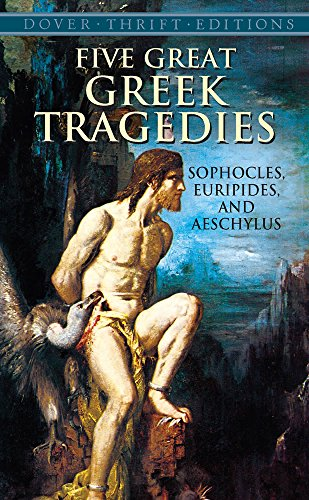Who wrote this book? This book, 'Five Great Greek Tragedies', features plays written by renowned Greek playwrights Sophocles, Euripides, and Aeschylus. 